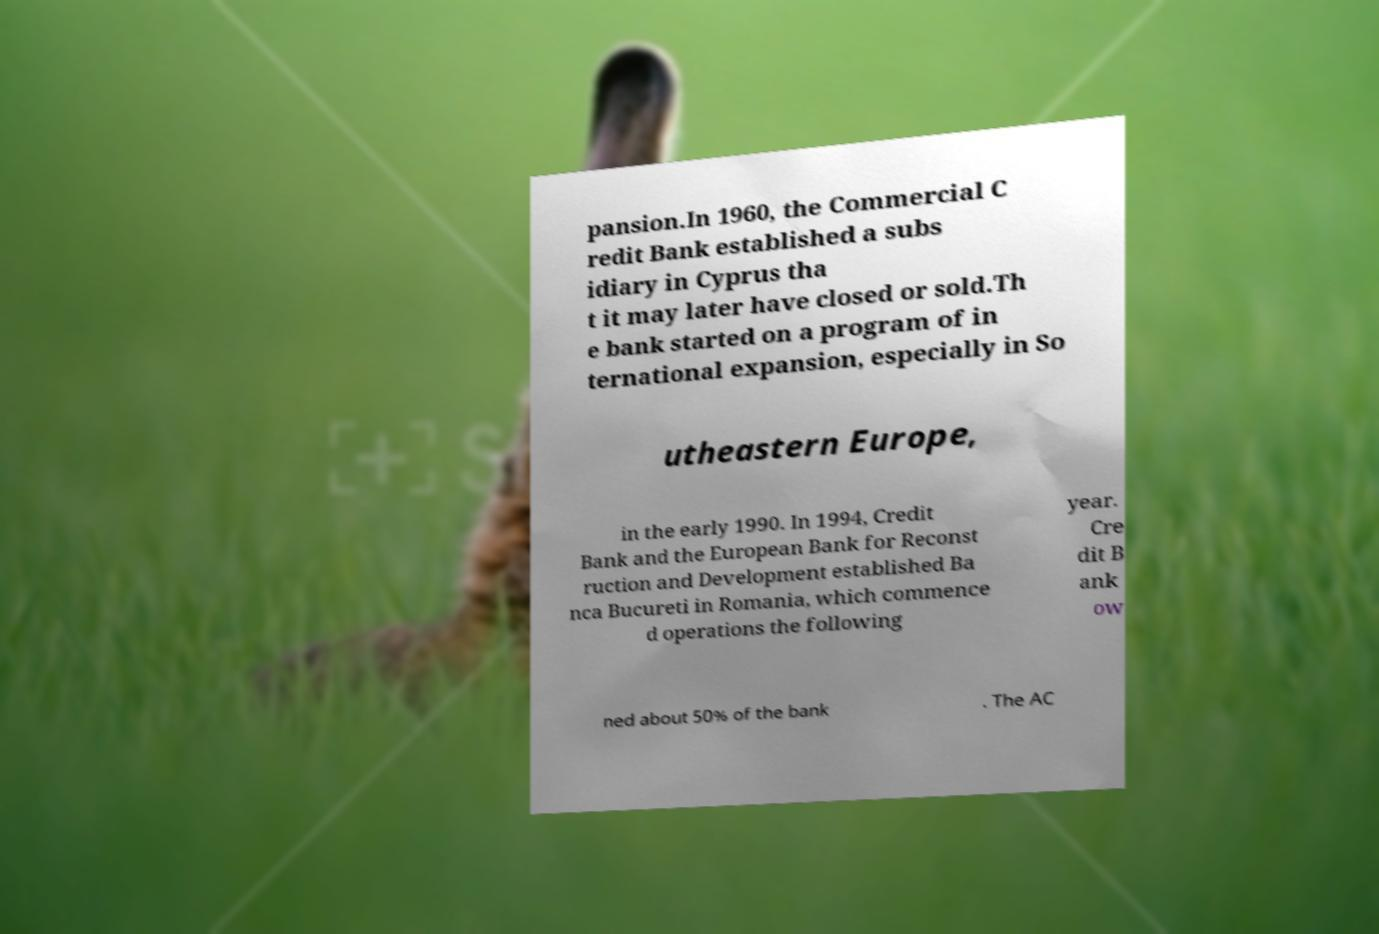Can you read and provide the text displayed in the image?This photo seems to have some interesting text. Can you extract and type it out for me? pansion.In 1960, the Commercial C redit Bank established a subs idiary in Cyprus tha t it may later have closed or sold.Th e bank started on a program of in ternational expansion, especially in So utheastern Europe, in the early 1990. In 1994, Credit Bank and the European Bank for Reconst ruction and Development established Ba nca Bucureti in Romania, which commence d operations the following year. Cre dit B ank ow ned about 50% of the bank . The AC 